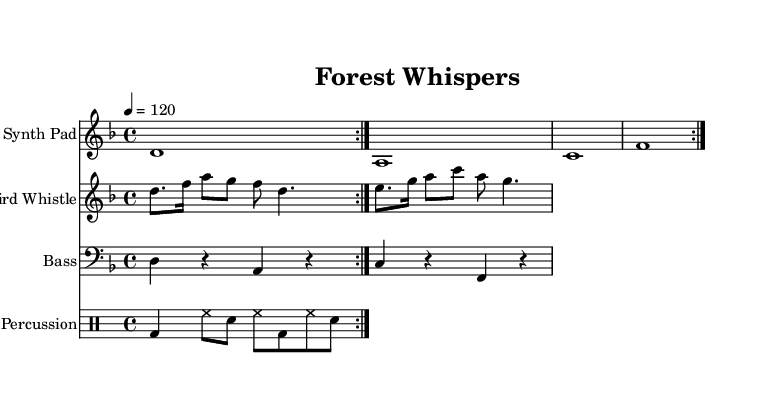What is the key signature of this music? The key signature shown in the music is D minor, which has one flat (B flat). This can be determined by looking at the key signature indicated at the beginning of the staff.
Answer: D minor What is the time signature of this music? The time signature displayed in the music is 4/4, which means there are four beats in each measure and the quarter note gets one beat. This can be seen in the time signature indication located at the beginning of the score.
Answer: 4/4 What is the tempo of the piece? The tempo marking indicates a speed of 120 beats per minute. This information is presented at the top of the score, showing how fast the piece should be played.
Answer: 120 How many measures are there in the “Synth Pad” part? The “Synth Pad” part consists of four measures, as visible in the music notation where each group of notes is enclosed within a measure line. Counting each group, we find four measures in total.
Answer: 4 What instrument is indicated for the main melody of the piece? The main melody of the piece is assigned to the “Bird Whistle” synthesizer, which is noted in the instrument name above its staff. The choice of this instrument suggests an atmospheric or naturalistic sound.
Answer: Bird Whistle What rhythmic pattern does the percussion part follow? The percussion part follows a repeated pattern of kick drum, hi-hat, and snare in the specified rhythm. Analyzing the drum notation, we see a sequence of bass drum, hi-hat, snare, repeated twice.
Answer: Bass-drum, hi-hat, snare What type of music is this score categorized as? This score is categorized as ambient house music, inspired by Finnish forest soundscapes, based on the ethereal nature of the synth sounds combined with natural elements like bird whistles. The overall mood and structure align with this genre.
Answer: Ambient house 